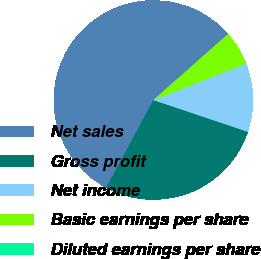Convert chart. <chart><loc_0><loc_0><loc_500><loc_500><pie_chart><fcel>Net sales<fcel>Gross profit<fcel>Net income<fcel>Basic earnings per share<fcel>Diluted earnings per share<nl><fcel>55.63%<fcel>27.68%<fcel>11.13%<fcel>5.56%<fcel>0.0%<nl></chart> 